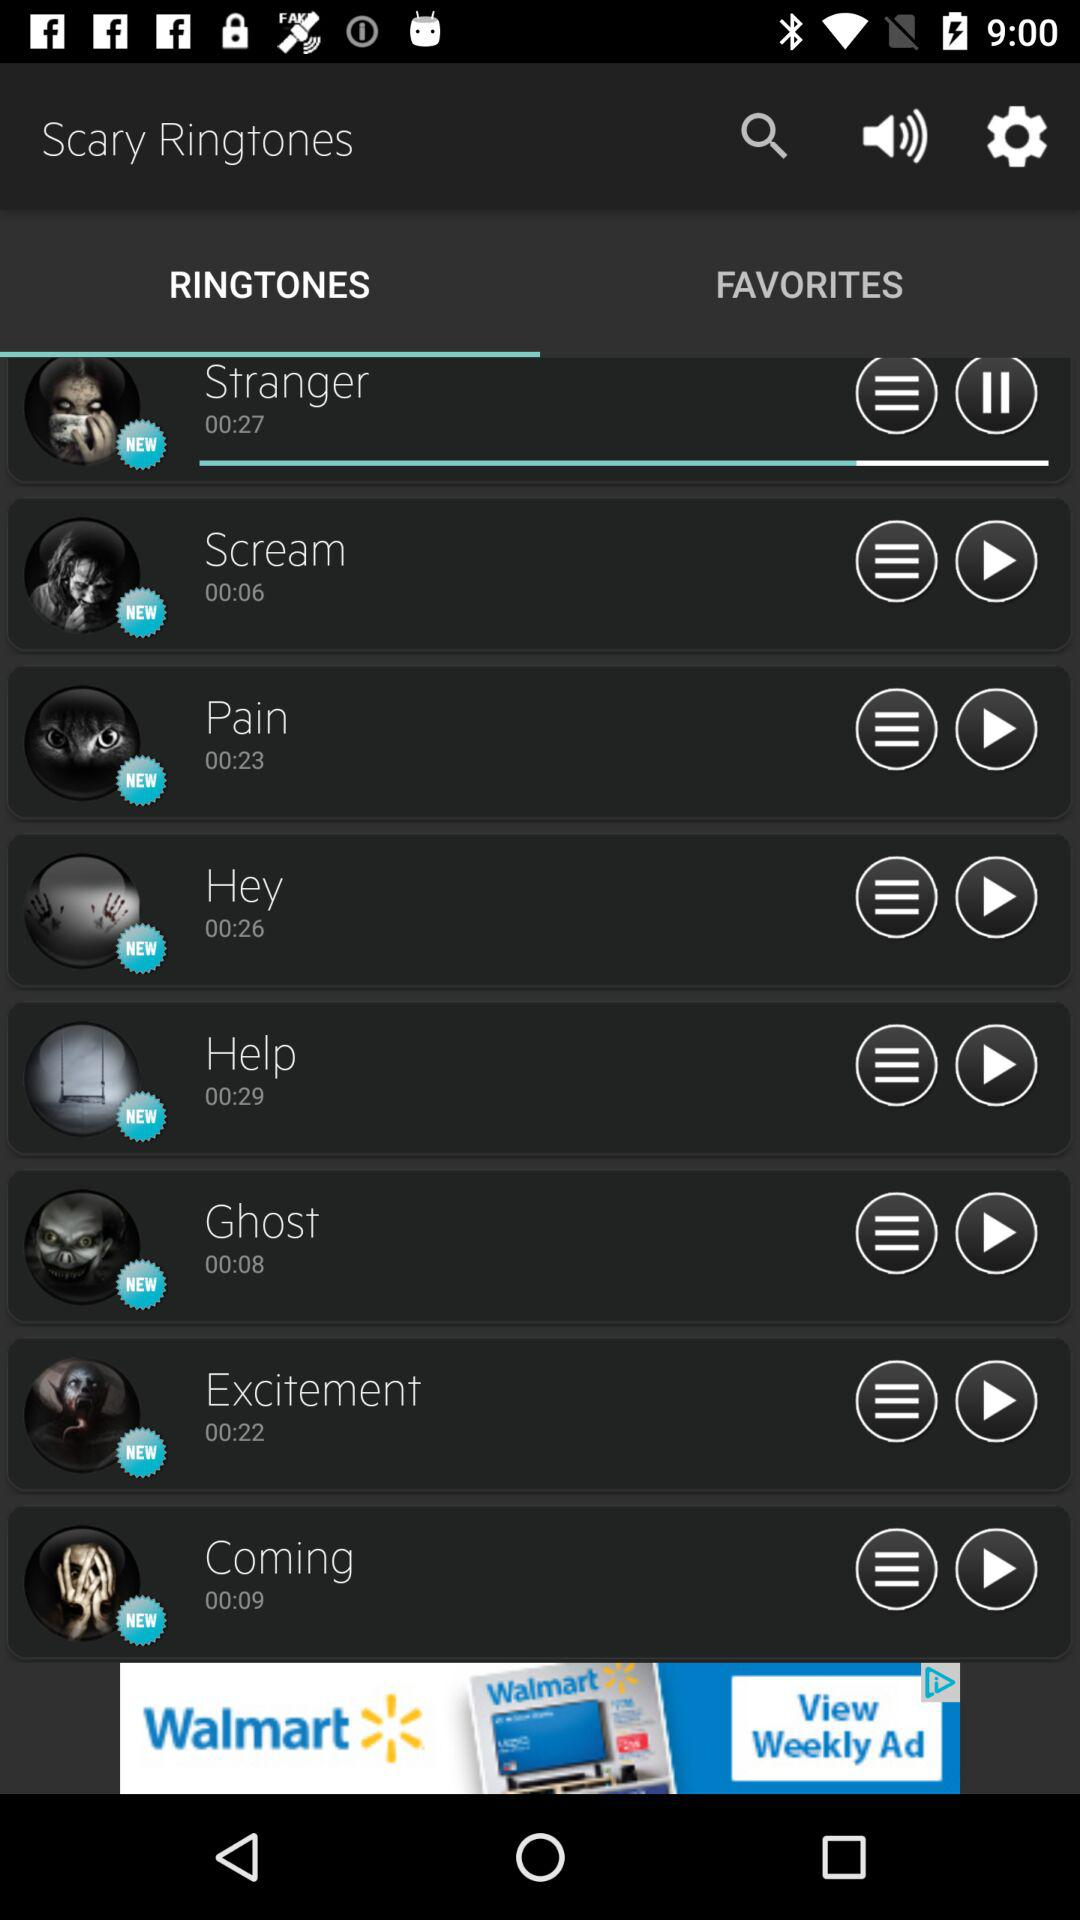What's the application name? The application name is "Scary Ringtones". 